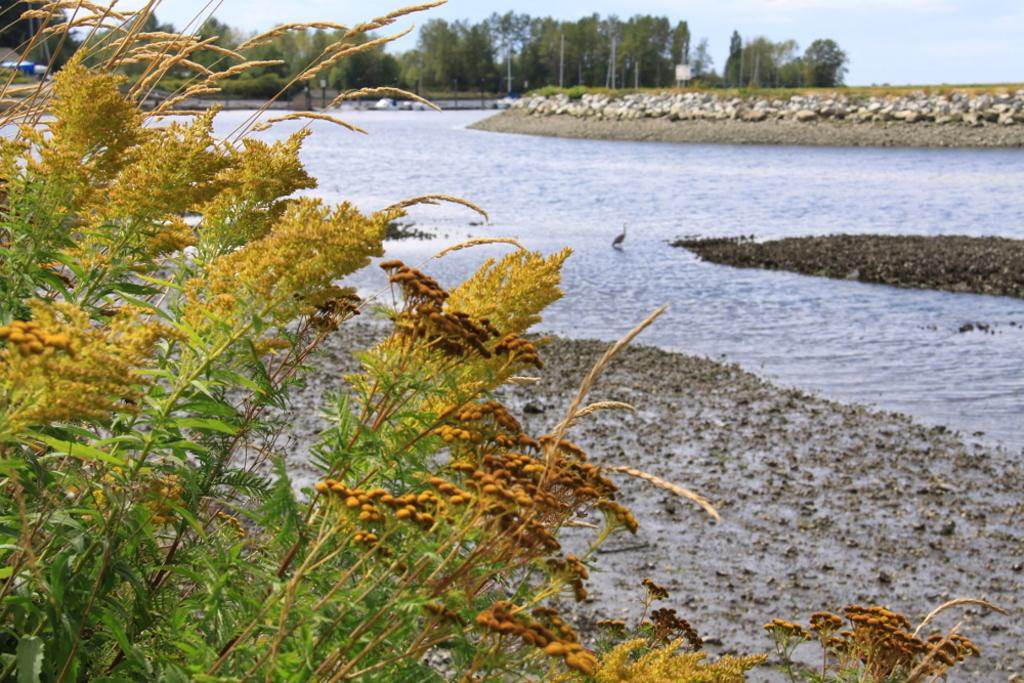What is located in the foreground of the image? There are plants in the foreground of the image. What is the main feature in the center of the image? There is a river in the center of the image. What can be seen in the background of the image? There are trees, grass, rocks, and poles in the background of the image. Can you see a tiger walking along the riverbank in the image? There is no tiger present in the image. Are there any goats grazing on the grass in the background of the image? There are no goats present in the image. 